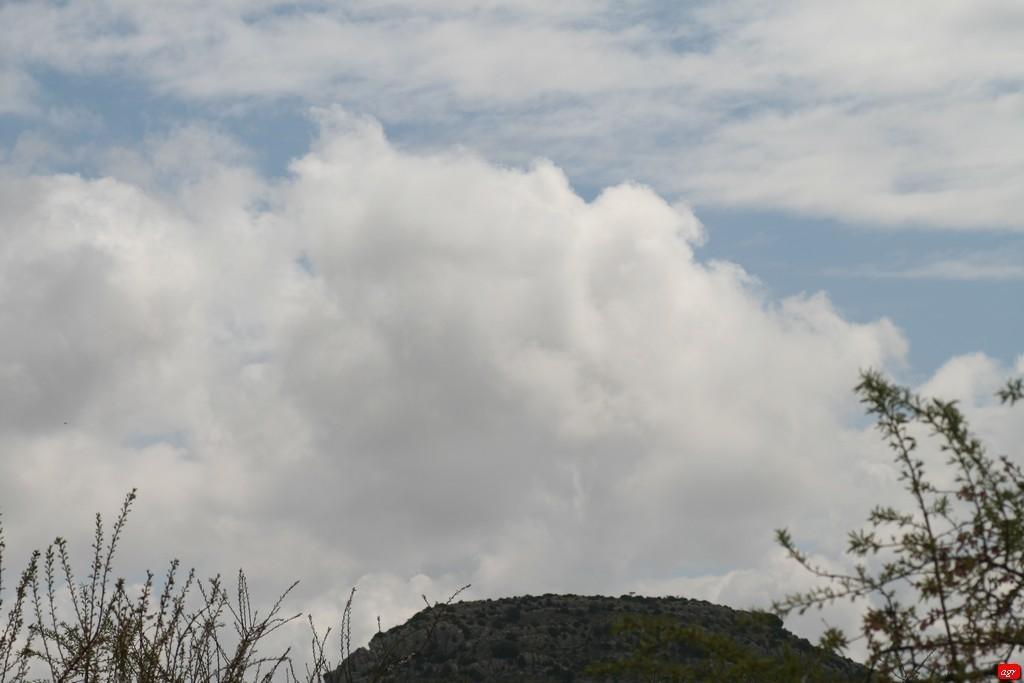Describe this image in one or two sentences. In this picture we can see some small plants in the front. Behind there is a sky and clouds. 